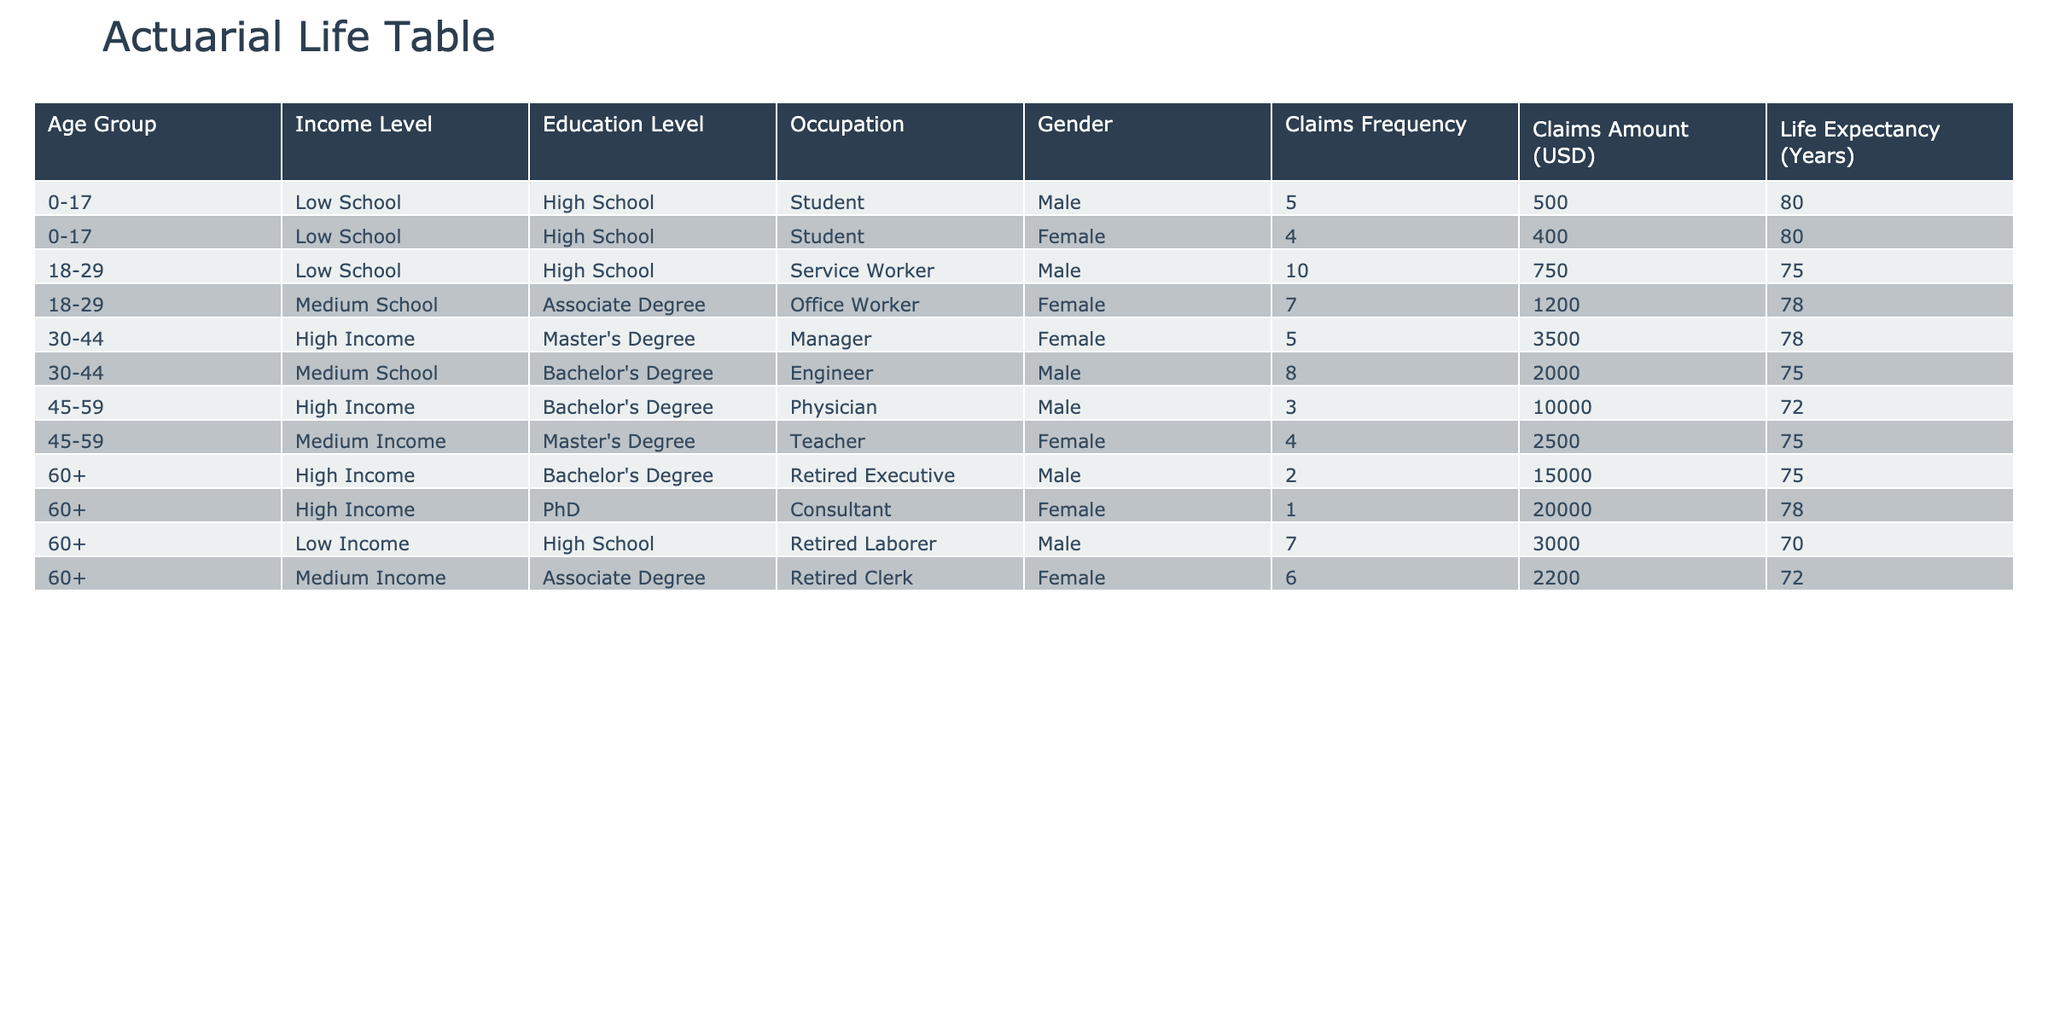What is the claims frequency for females in the age group 45-59? From the table, in the age group 45-59, the entry for females shows a claims frequency of 4.
Answer: 4 What is the average claims amount for all male participants? To find the average, we sum the claims amounts for males: 500 + 750 + 2000 + 10000 + 3000 + 15000 = 22800. There are 6 male entries, so the average is 22800/6 = 3800.
Answer: 3800 Is the life expectancy for high-income individuals in the age group 60+ higher than that of medium-income individuals in the same age group? In the 60+ group, high-income individuals have a life expectancy of 75 years, while medium-income individuals have a life expectancy of 72 years. Since 75 > 72, the statement is true.
Answer: Yes What is the total claims amount for all individuals in the age group 0-17? For the age group 0-17, we have claims amounts of 500 and 400. Summing these gives 500 + 400 = 900.
Answer: 900 Which occupation has the highest claims frequency, and what is that frequency? Checking the table, the occupation "Service Worker" in the 18-29 age group has the highest claims frequency of 10.
Answer: Service Worker, 10 Compare the claims amounts for the lowest and highest income levels among individuals who are 30-44 years old. What is the difference? For the 30-44 age group, the low-income claims amount (not listed as an income level) should not be compared. However, the high-income amount is from the female manager: 3500. Thus, there is no low-income data to compare.
Answer: Not applicable What is the total claims amount for females across all age groups? The total for females is calculated as follows: 400 (0-17) + 1200 (18-29) + 3500 (30-44) + 2500 (45-59) + 2200 (60+) + 20000 (60+) =  28800.
Answer: 28800 Is there an individual in the table who has both a Master’s Degree and a claims frequency of 4 or more? Checking the data, the female teacher with a Master's Degree (45-59 age group) has a claims frequency of 4; this satisfies the condition.
Answer: Yes 